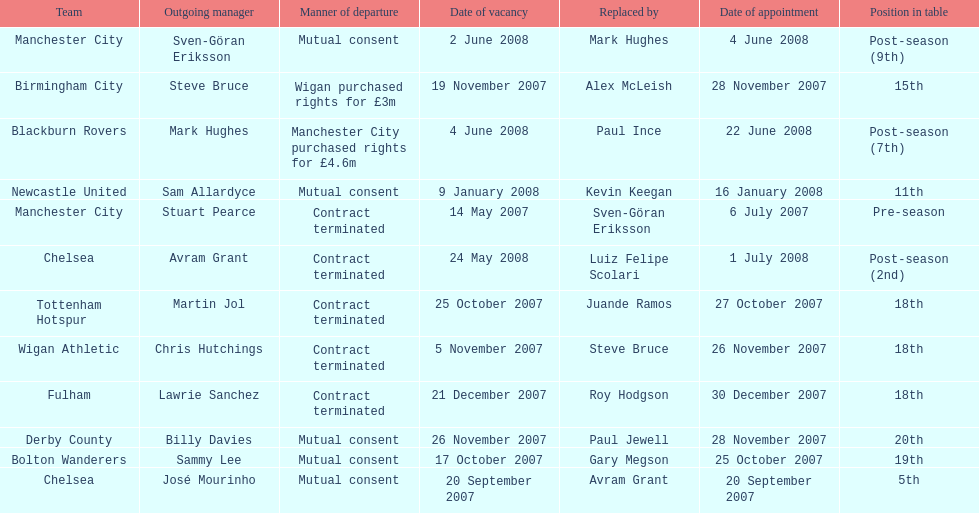What was the only team to place 5th called? Chelsea. 